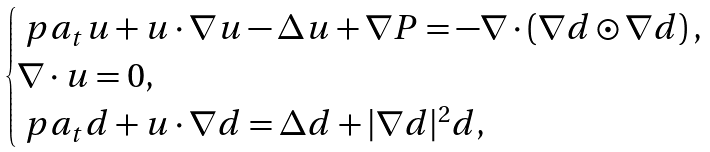Convert formula to latex. <formula><loc_0><loc_0><loc_500><loc_500>\begin{cases} \ p a _ { t } u + u \cdot \nabla u - \Delta u + \nabla P = - \nabla \cdot \left ( \nabla d \odot \nabla d \right ) , \\ \nabla \cdot u = 0 , \\ \ p a _ { t } d + u \cdot \nabla d = \Delta d + | \nabla d | ^ { 2 } d , \end{cases}</formula> 